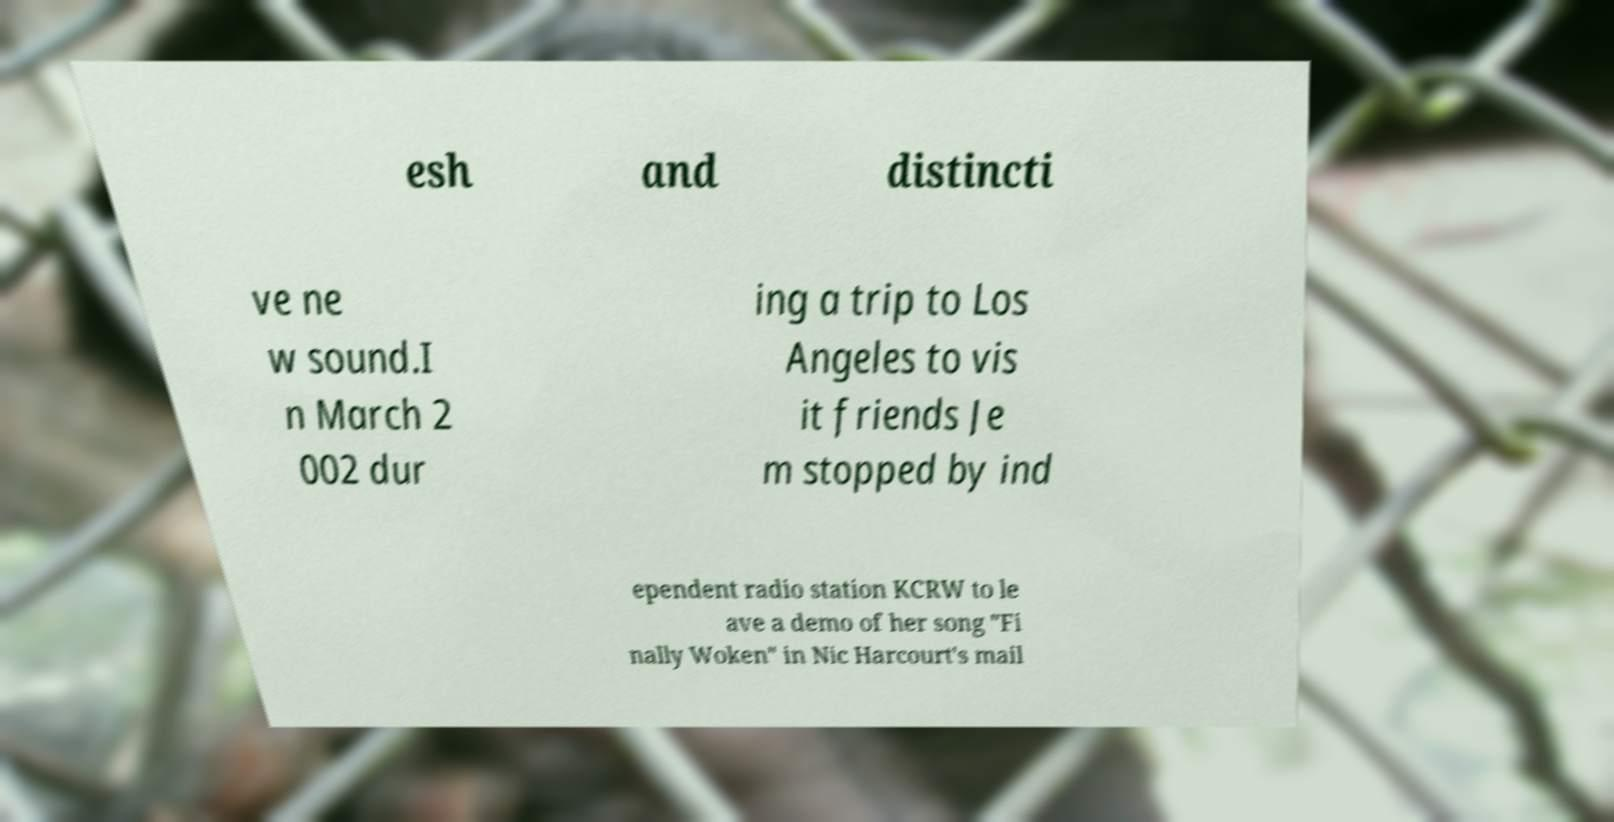Please read and relay the text visible in this image. What does it say? esh and distincti ve ne w sound.I n March 2 002 dur ing a trip to Los Angeles to vis it friends Je m stopped by ind ependent radio station KCRW to le ave a demo of her song "Fi nally Woken" in Nic Harcourt's mail 